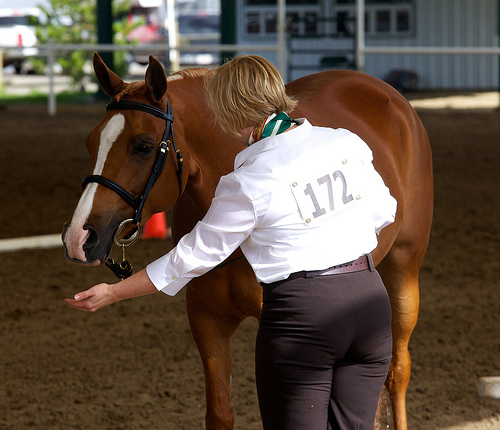<image>
Is the lady on the horse? No. The lady is not positioned on the horse. They may be near each other, but the lady is not supported by or resting on top of the horse. 